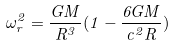Convert formula to latex. <formula><loc_0><loc_0><loc_500><loc_500>\omega _ { r } ^ { 2 } = \frac { G M } { R ^ { 3 } } ( 1 - \frac { 6 G M } { c ^ { 2 } R } )</formula> 